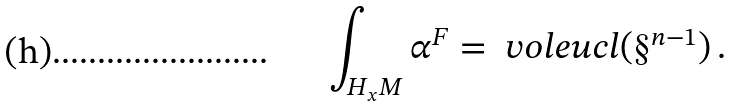<formula> <loc_0><loc_0><loc_500><loc_500>\int _ { H _ { x } M } \alpha ^ { F } = \ v o l e u c l ( \S ^ { n - 1 } ) \, .</formula> 